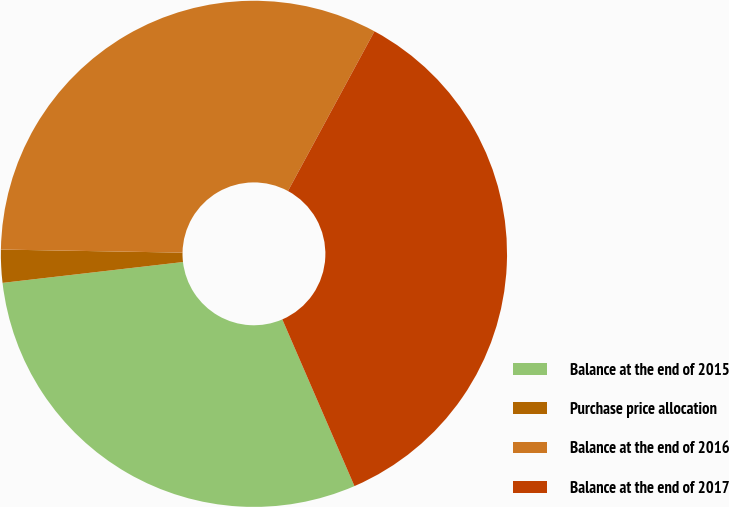Convert chart. <chart><loc_0><loc_0><loc_500><loc_500><pie_chart><fcel>Balance at the end of 2015<fcel>Purchase price allocation<fcel>Balance at the end of 2016<fcel>Balance at the end of 2017<nl><fcel>29.67%<fcel>2.1%<fcel>32.63%<fcel>35.6%<nl></chart> 